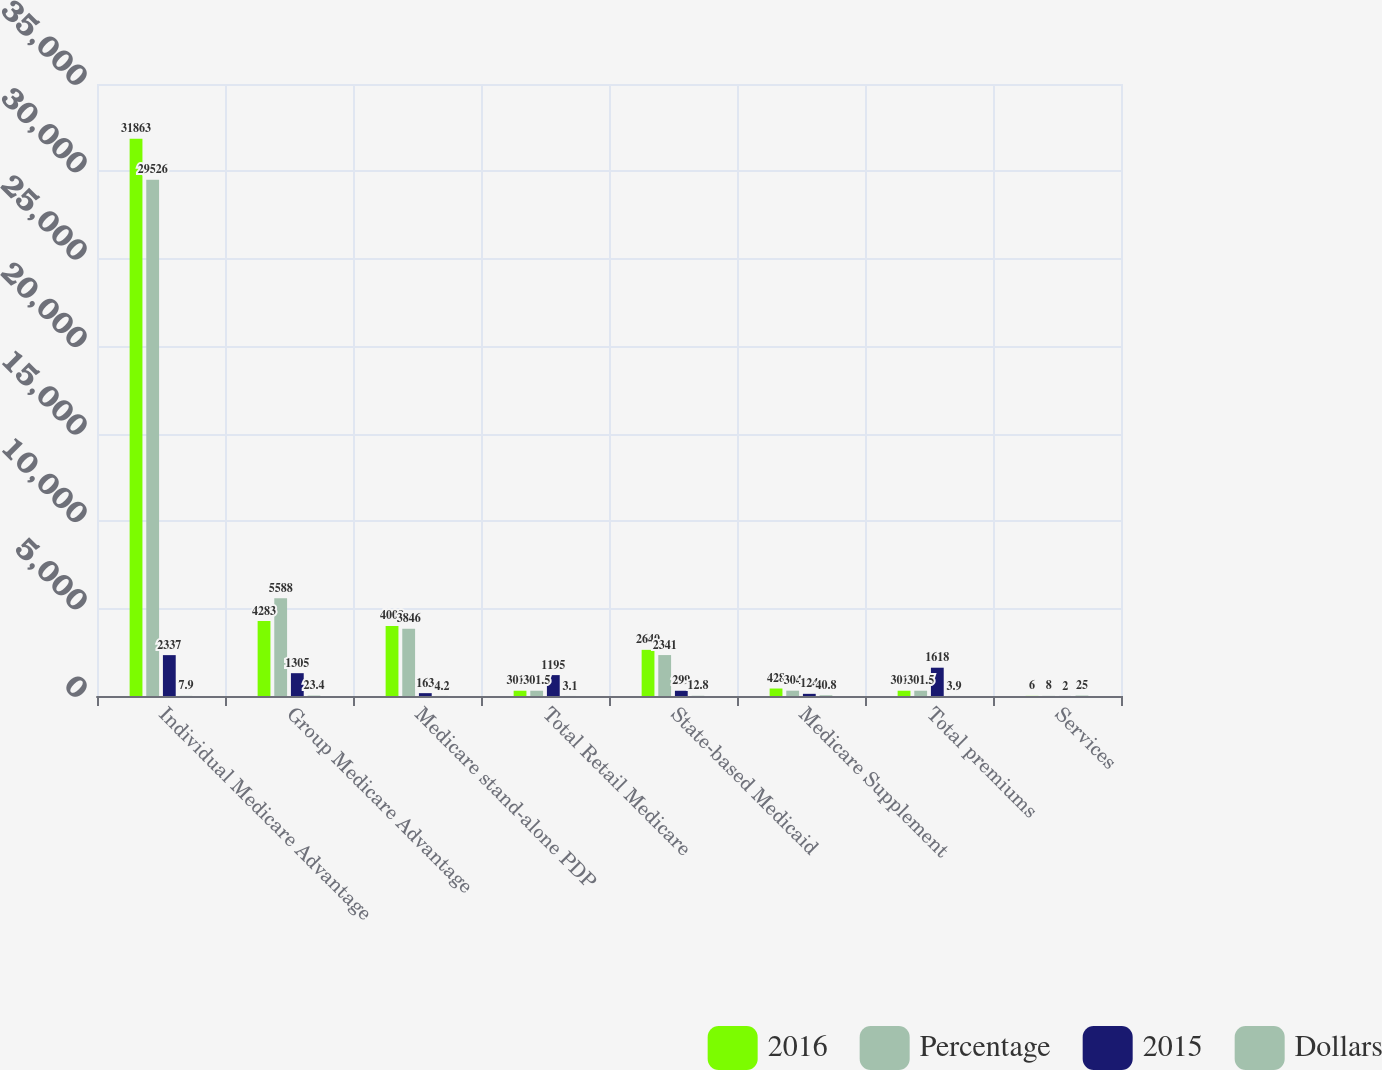<chart> <loc_0><loc_0><loc_500><loc_500><stacked_bar_chart><ecel><fcel>Individual Medicare Advantage<fcel>Group Medicare Advantage<fcel>Medicare stand-alone PDP<fcel>Total Retail Medicare<fcel>State-based Medicaid<fcel>Medicare Supplement<fcel>Total premiums<fcel>Services<nl><fcel>2016<fcel>31863<fcel>4283<fcel>4009<fcel>301.5<fcel>2640<fcel>428<fcel>301.5<fcel>6<nl><fcel>Percentage<fcel>29526<fcel>5588<fcel>3846<fcel>301.5<fcel>2341<fcel>304<fcel>301.5<fcel>8<nl><fcel>2015<fcel>2337<fcel>1305<fcel>163<fcel>1195<fcel>299<fcel>124<fcel>1618<fcel>2<nl><fcel>Dollars<fcel>7.9<fcel>23.4<fcel>4.2<fcel>3.1<fcel>12.8<fcel>40.8<fcel>3.9<fcel>25<nl></chart> 